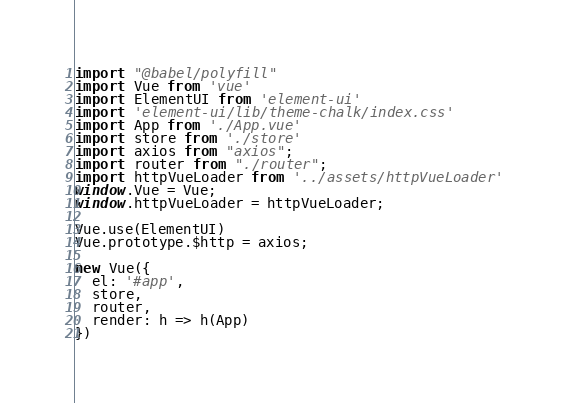Convert code to text. <code><loc_0><loc_0><loc_500><loc_500><_JavaScript_>import "@babel/polyfill"
import Vue from 'vue'
import ElementUI from 'element-ui'
import 'element-ui/lib/theme-chalk/index.css'
import App from './App.vue'
import store from './store'
import axios from "axios";
import router from "./router";
import httpVueLoader from '../assets/httpVueLoader'
window.Vue = Vue;
window.httpVueLoader = httpVueLoader;

Vue.use(ElementUI)
Vue.prototype.$http = axios;

new Vue({
  el: '#app',
  store,
  router,
  render: h => h(App)
})
</code> 